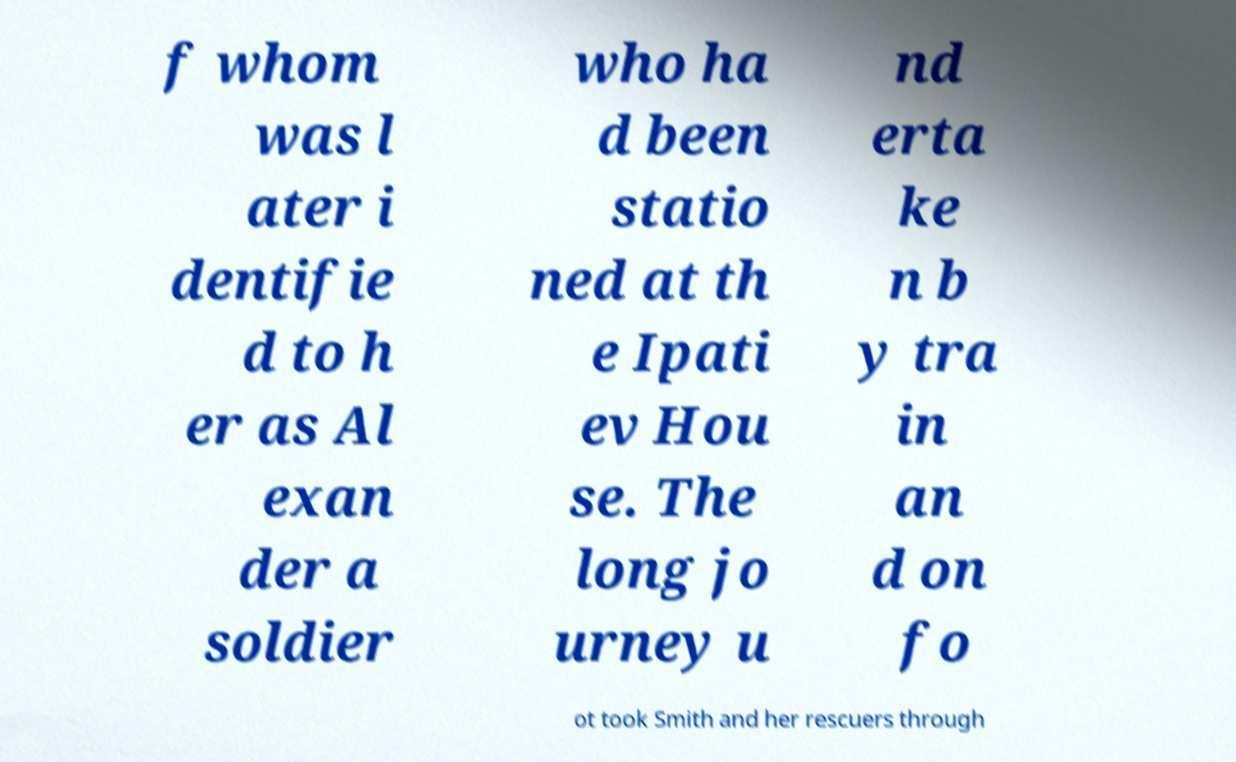I need the written content from this picture converted into text. Can you do that? f whom was l ater i dentifie d to h er as Al exan der a soldier who ha d been statio ned at th e Ipati ev Hou se. The long jo urney u nd erta ke n b y tra in an d on fo ot took Smith and her rescuers through 